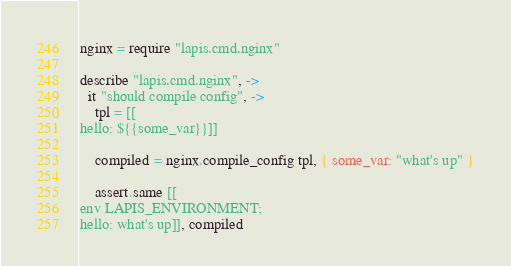Convert code to text. <code><loc_0><loc_0><loc_500><loc_500><_MoonScript_>
nginx = require "lapis.cmd.nginx"

describe "lapis.cmd.nginx", ->
  it "should compile config", ->
    tpl = [[
hello: ${{some_var}}]]

    compiled = nginx.compile_config tpl, { some_var: "what's up" }

    assert.same [[
env LAPIS_ENVIRONMENT;
hello: what's up]], compiled
</code> 